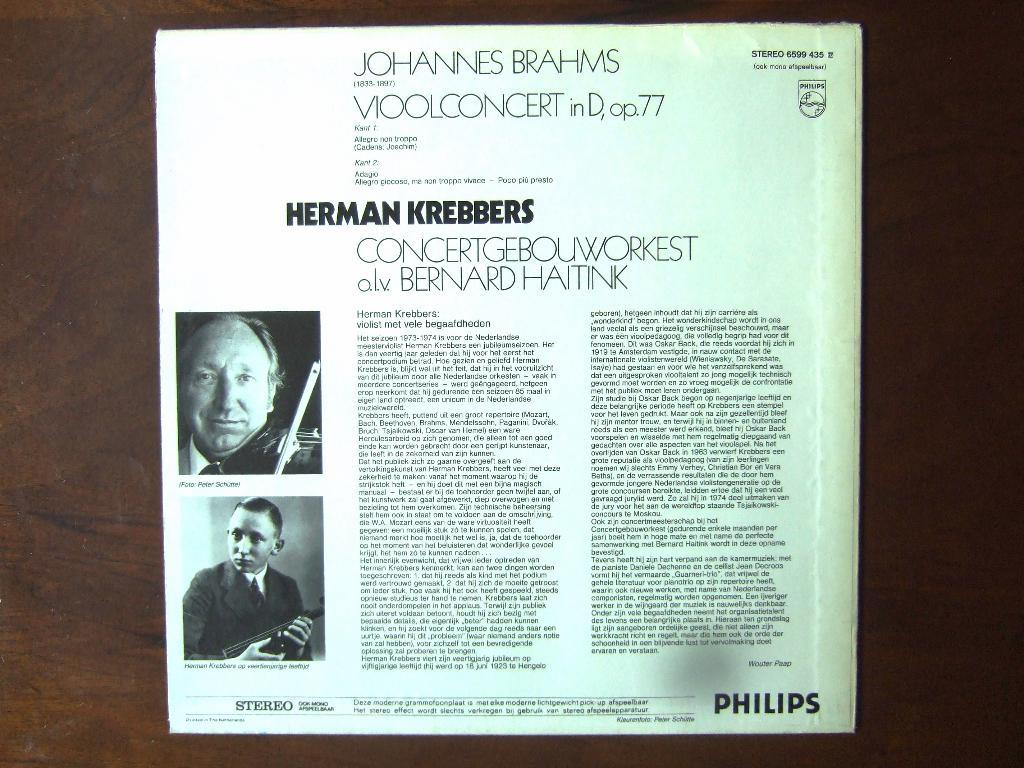What is present on the poster in the image? The poster has text and images on it. Where is the poster located in the image? The poster is on a table. Is there a garden visible in the image? No, there is no garden present in the image. Is the poster being attacked by any animals in the image? No, there are no animals or any form of attack present in the image. 